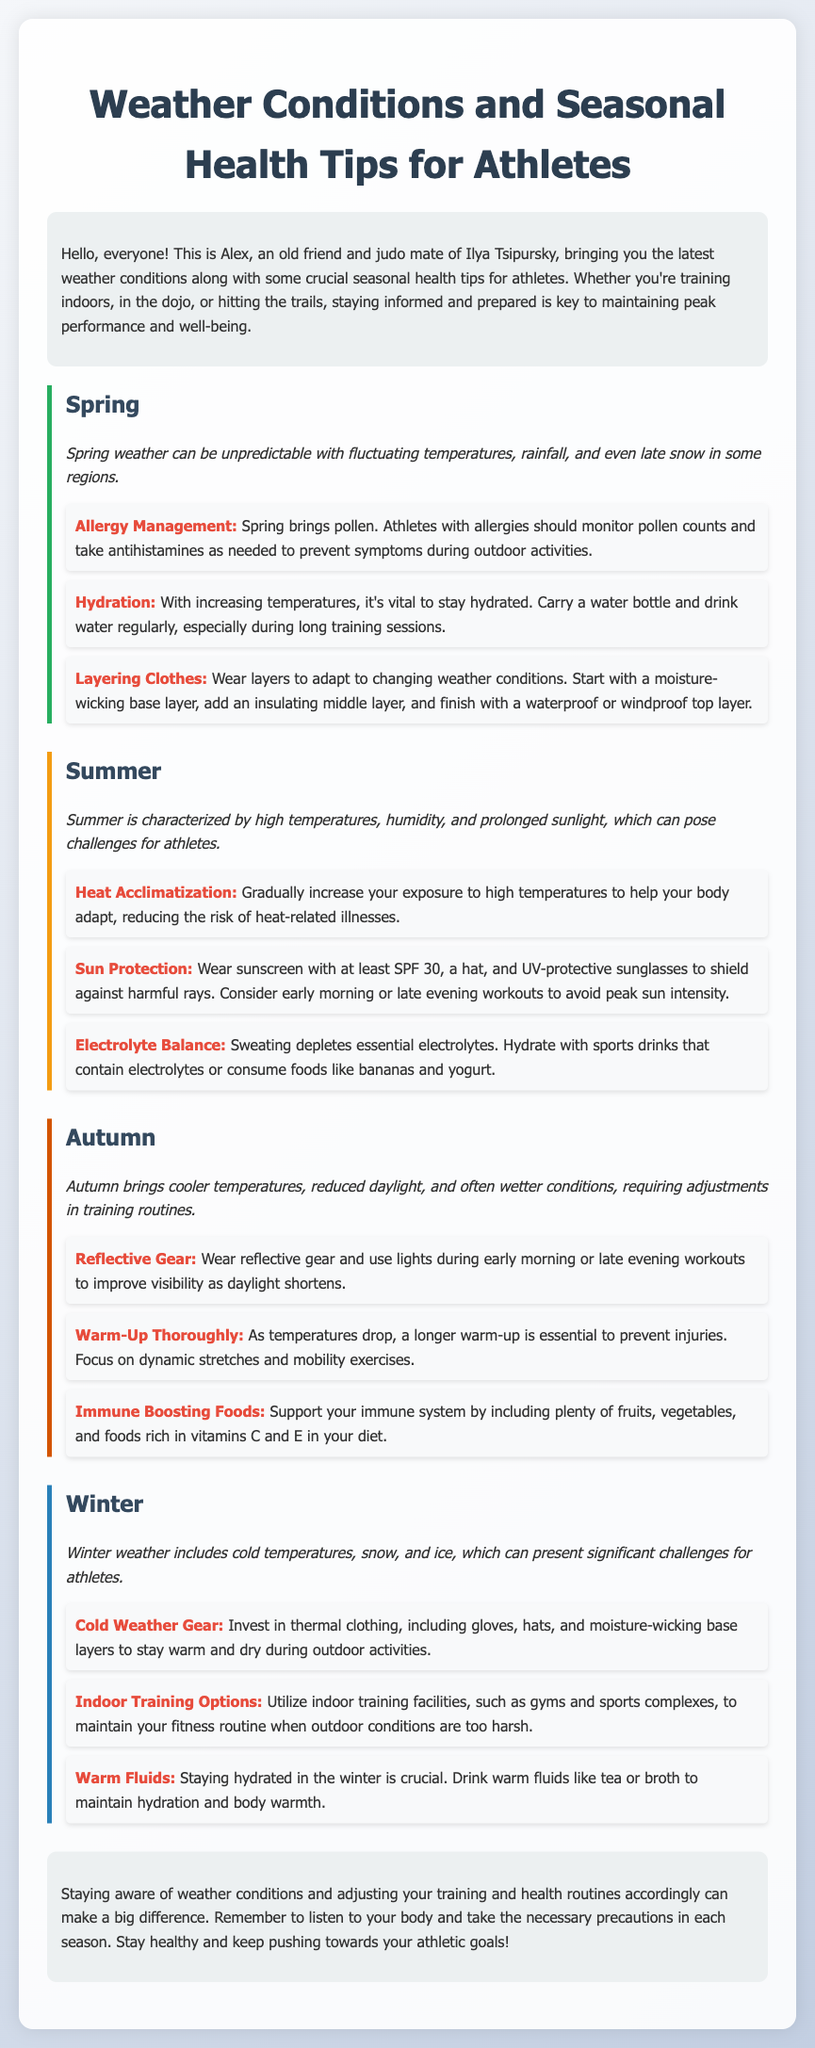What is the primary focus of the document? The document provides information on weather conditions and health tips for athletes across different seasons.
Answer: Weather conditions and seasonal health tips for athletes How many seasons are covered in the document? The document discusses health tips and conditions for Spring, Summer, Autumn, and Winter, totaling four seasons.
Answer: Four What should athletes wear in Spring for changing weather? The document suggests wearing layers, including a moisture-wicking base layer, an insulating middle layer, and a waterproof or windproof top layer.
Answer: Layers What is one key health tip for Summer? The document emphasizes heat acclimatization to help athletes adapt to high temperatures.
Answer: Heat acclimatization During which season is it advised to wear reflective gear? The document recommends wearing reflective gear during Autumn, especially as daylight decreases.
Answer: Autumn What is a recommended food type for boosting immunity in Autumn? The document suggests including plenty of fruits and vegetables, which are rich in vitamins C and E, in the diet for immune support.
Answer: Fruits and vegetables What type of clothing is suggested for Winter? The document advises athletes to invest in thermal clothing, including gloves and hats, to stay warm during outdoor activities.
Answer: Thermal clothing What is a hydration tip for Winter? The document suggests drinking warm fluids like tea or broth to maintain hydration and body warmth during Winter.
Answer: Warm fluids What is the purpose of the conclusion in the document? The conclusion emphasizes the importance of being aware of weather conditions and adjusting training and health routines accordingly.
Answer: Stay aware of weather conditions 